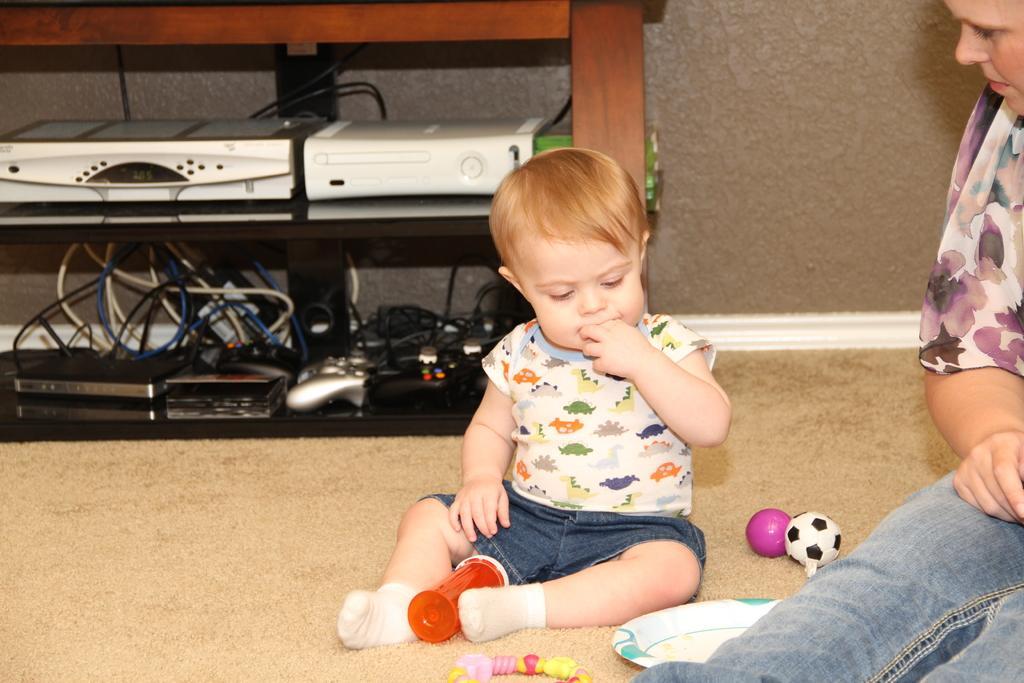How would you summarize this image in a sentence or two? This is the picture of a room. In this image there are two persons sitting and there are toys and there is a plate in the bottom. At the back there are devices and wires in the cupboard. At the bottom there is a mat. At the back there's a wall. 